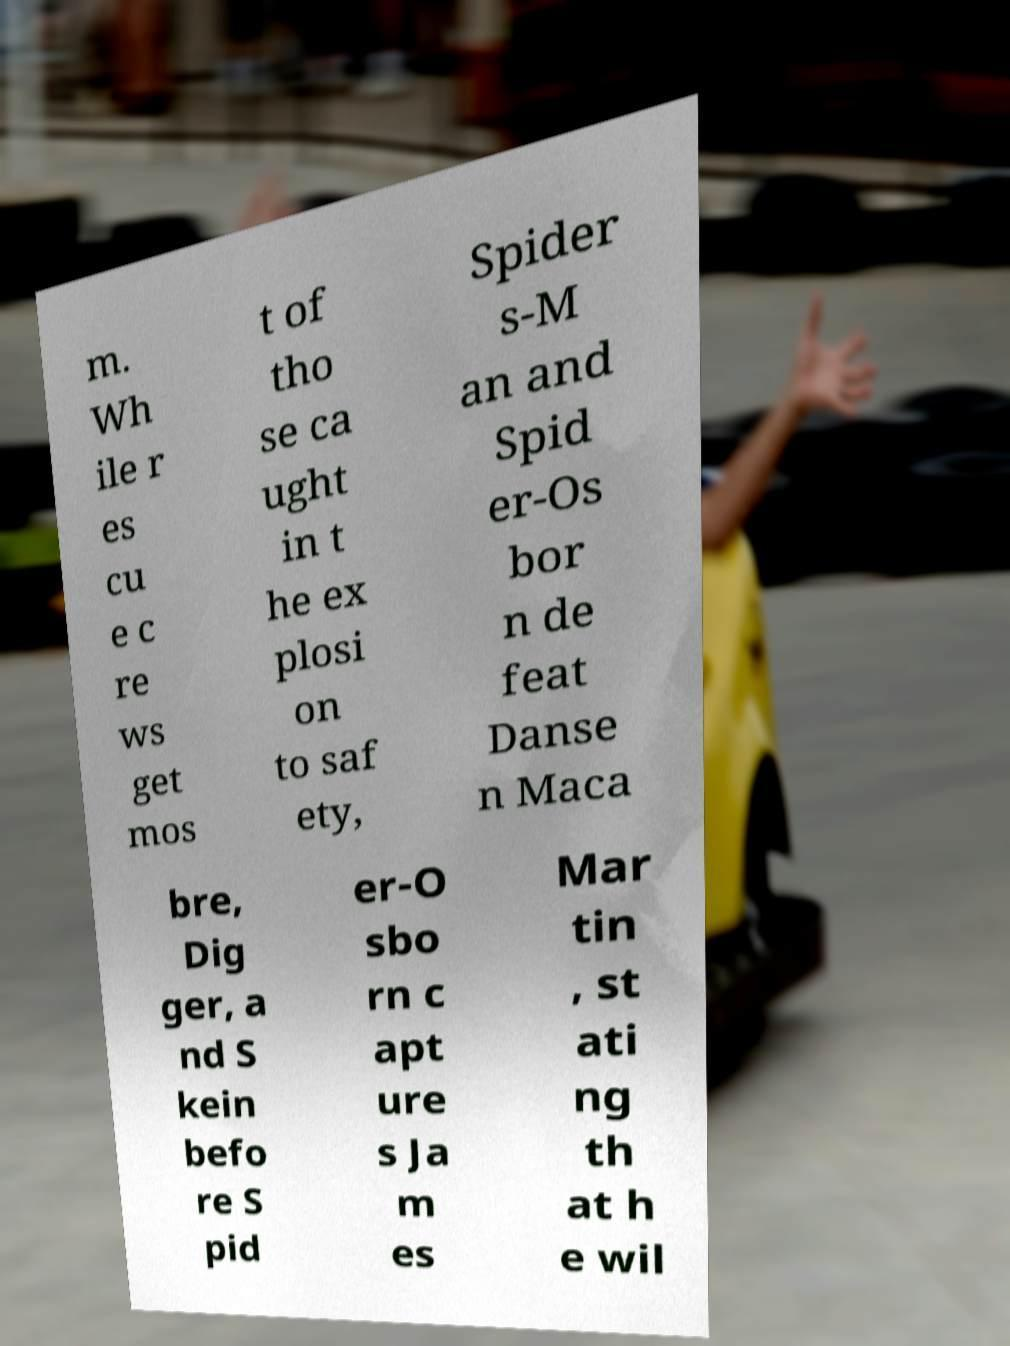For documentation purposes, I need the text within this image transcribed. Could you provide that? m. Wh ile r es cu e c re ws get mos t of tho se ca ught in t he ex plosi on to saf ety, Spider s-M an and Spid er-Os bor n de feat Danse n Maca bre, Dig ger, a nd S kein befo re S pid er-O sbo rn c apt ure s Ja m es Mar tin , st ati ng th at h e wil 